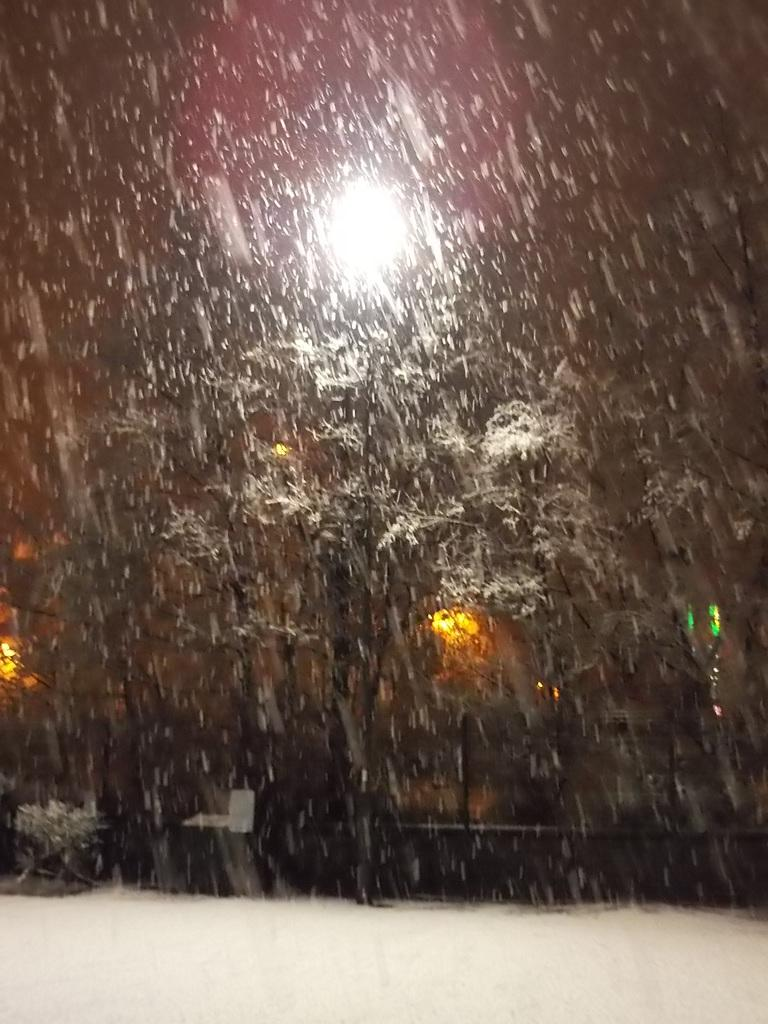What type of vegetation can be seen in the image? There are trees in the image. What is the weather like in the image? There is snow in the image, indicating a cold or wintery environment. Are there any artificial light sources in the image? Yes, there are lights in the image. Can you describe the unspecified objects in the image? Unfortunately, the provided facts do not specify the nature of these objects, so we cannot describe them. How many sticks are being used by the girls in the image? There are no sticks or girls present in the image. What type of chain can be seen connecting the lights in the image? There is no chain connecting the lights in the image; the lights are not specified as being connected in any way. 